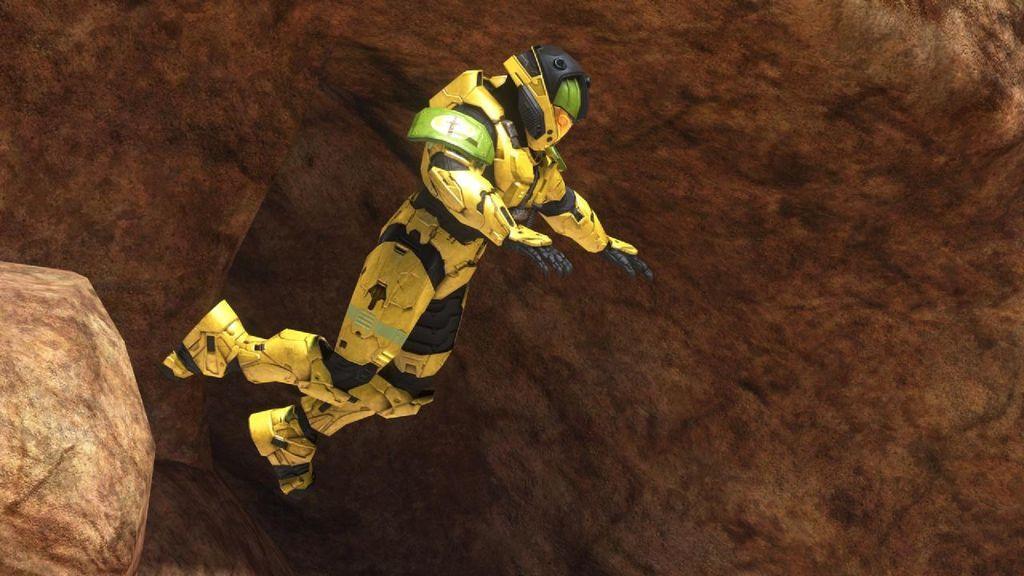How would you summarize this image in a sentence or two? In this image we can see a person in the air wearing a helmet and a yellow costume. In the background we can see rocks. 